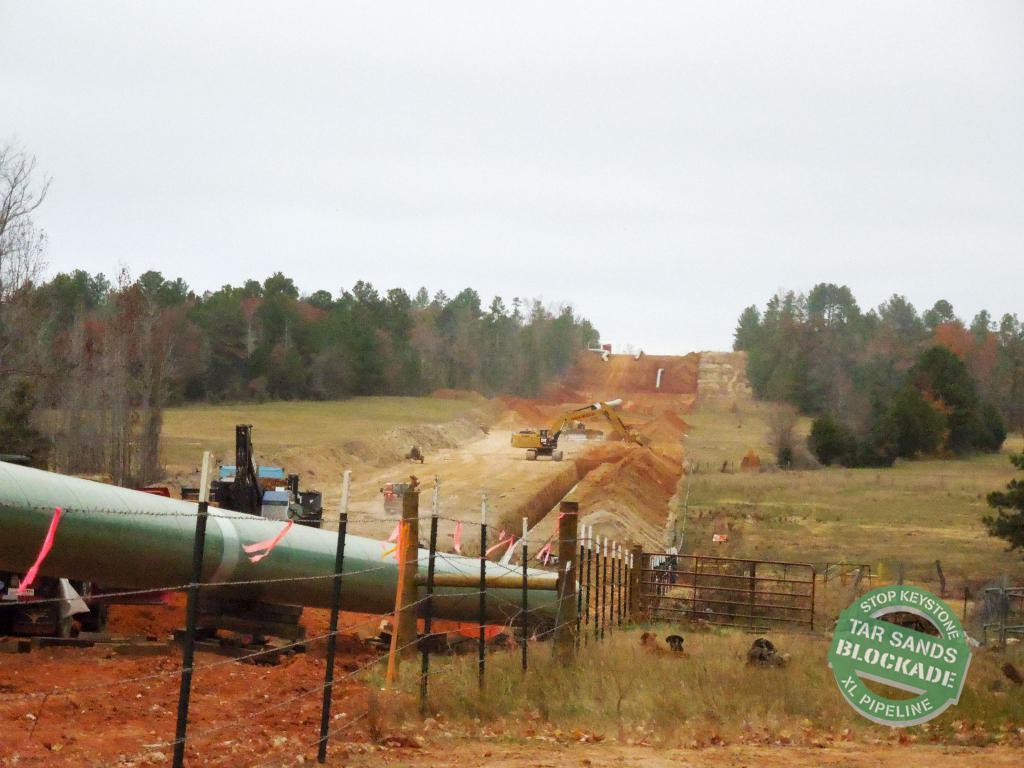Can you describe this image briefly? In the given image i can see a vehicle's,fence,trees,grass,sand,plants and in the background i can see the sky. 